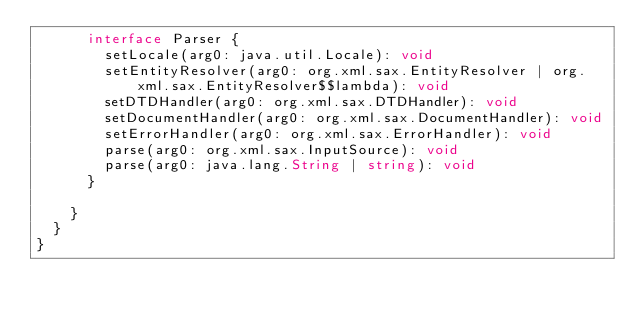Convert code to text. <code><loc_0><loc_0><loc_500><loc_500><_TypeScript_>      interface Parser {
        setLocale(arg0: java.util.Locale): void
        setEntityResolver(arg0: org.xml.sax.EntityResolver | org.xml.sax.EntityResolver$$lambda): void
        setDTDHandler(arg0: org.xml.sax.DTDHandler): void
        setDocumentHandler(arg0: org.xml.sax.DocumentHandler): void
        setErrorHandler(arg0: org.xml.sax.ErrorHandler): void
        parse(arg0: org.xml.sax.InputSource): void
        parse(arg0: java.lang.String | string): void
      }

    }
  }
}
</code> 